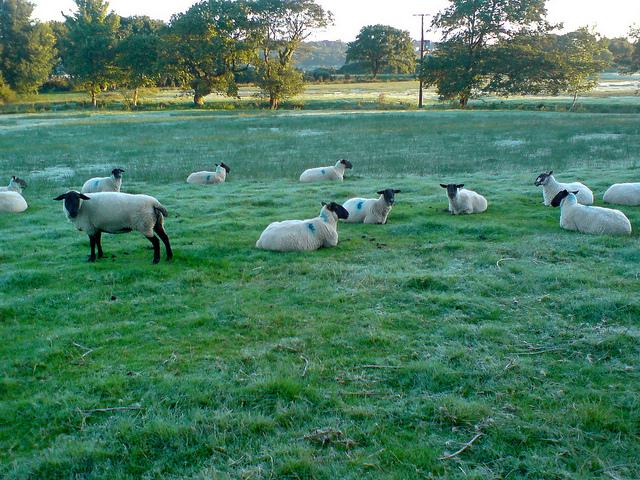Are the sheep laying in the grass?
Quick response, please. Yes. Are there more sheep on one side of the pole than the other?
Keep it brief. Yes. What animal is this?
Concise answer only. Sheep. How many sheep?
Be succinct. 11. 